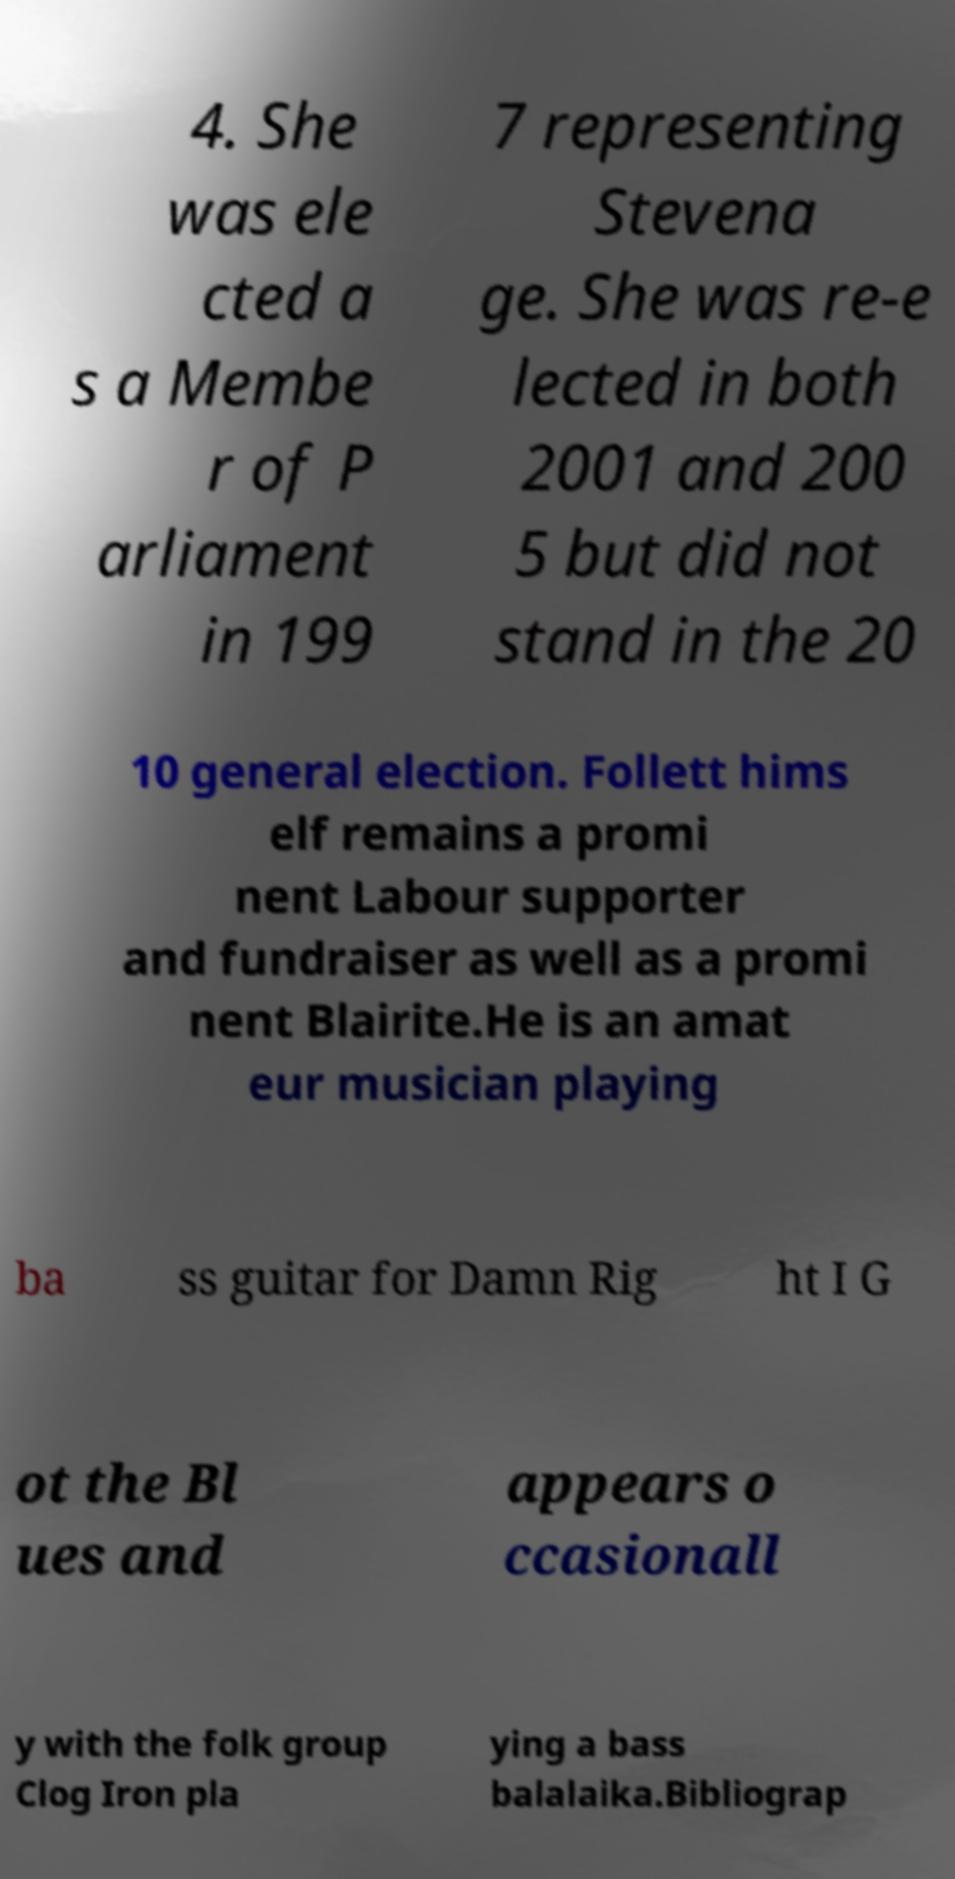Could you assist in decoding the text presented in this image and type it out clearly? 4. She was ele cted a s a Membe r of P arliament in 199 7 representing Stevena ge. She was re-e lected in both 2001 and 200 5 but did not stand in the 20 10 general election. Follett hims elf remains a promi nent Labour supporter and fundraiser as well as a promi nent Blairite.He is an amat eur musician playing ba ss guitar for Damn Rig ht I G ot the Bl ues and appears o ccasionall y with the folk group Clog Iron pla ying a bass balalaika.Bibliograp 